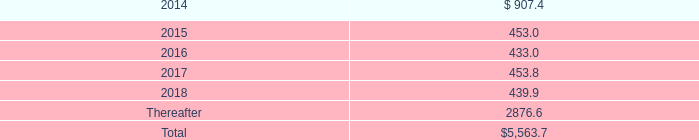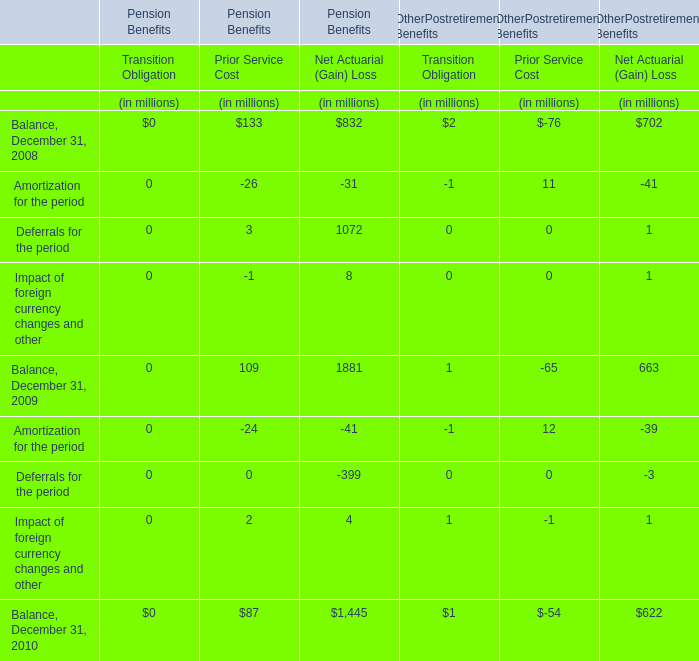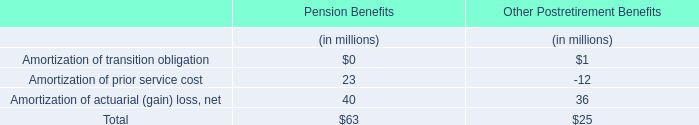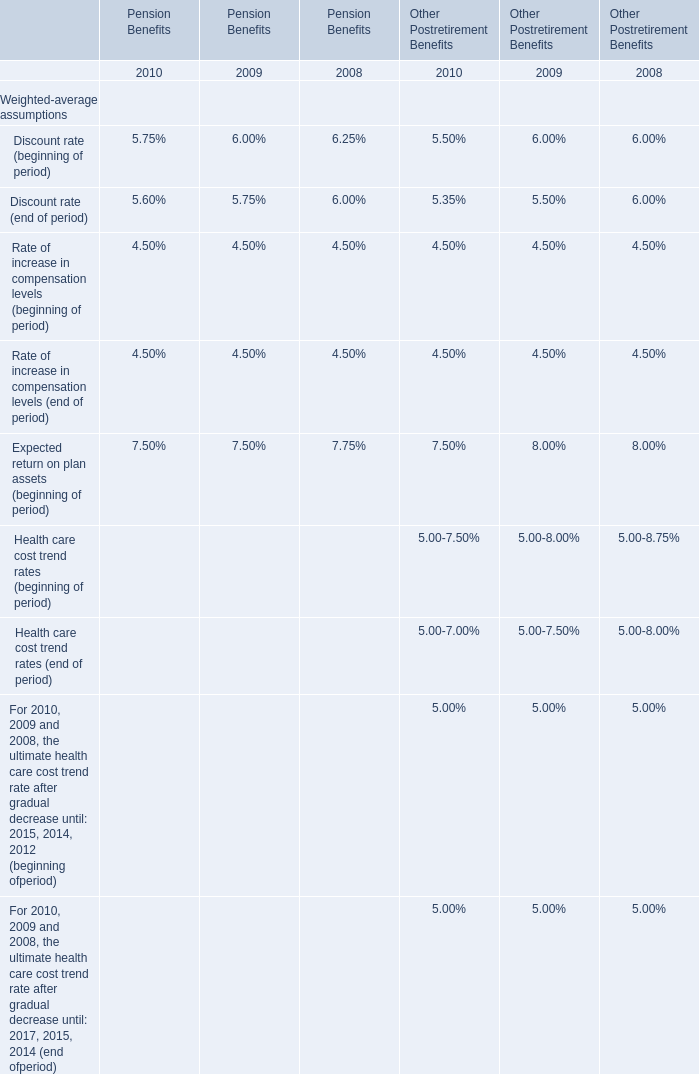what is going to be the matured value of the $ 400.0 issued in 2013? 
Computations: (400.0 * exp((1 + 2.75%))
Answer: 524.66041. 